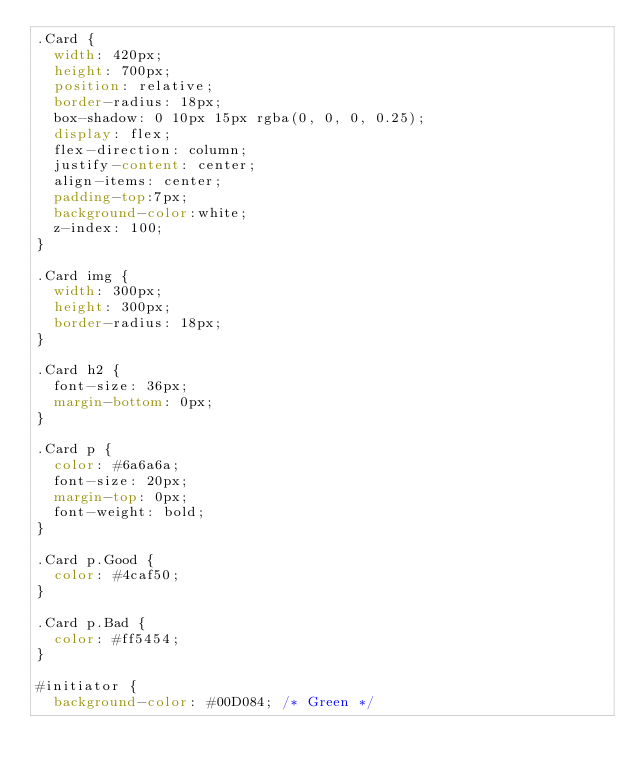Convert code to text. <code><loc_0><loc_0><loc_500><loc_500><_CSS_>.Card {
  width: 420px;
  height: 700px;
  position: relative;
  border-radius: 18px;
  box-shadow: 0 10px 15px rgba(0, 0, 0, 0.25);
  display: flex;
  flex-direction: column;
  justify-content: center;
  align-items: center;
  padding-top:7px;
  background-color:white;
  z-index: 100;
}

.Card img {
  width: 300px;
  height: 300px;
  border-radius: 18px;
}

.Card h2 {
  font-size: 36px;
  margin-bottom: 0px;
}

.Card p {
  color: #6a6a6a;
  font-size: 20px;
  margin-top: 0px;
  font-weight: bold;
}

.Card p.Good {
  color: #4caf50;
}

.Card p.Bad {
  color: #ff5454;
}

#initiator {
  background-color: #00D084; /* Green */</code> 